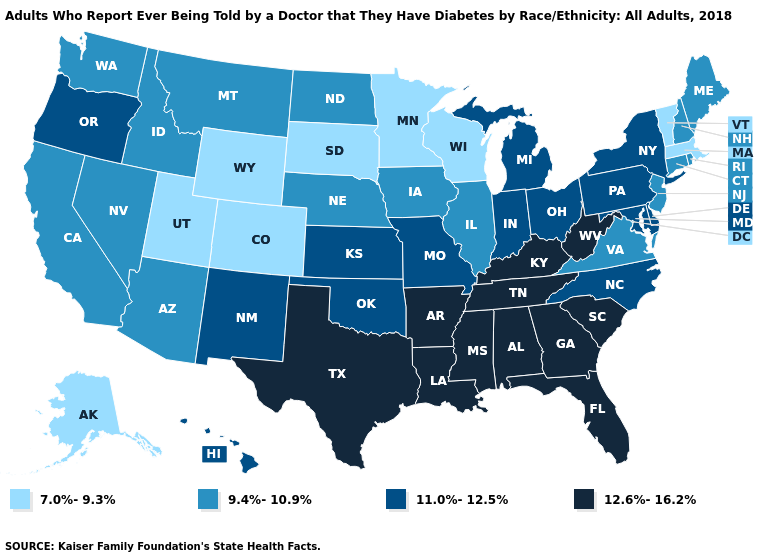Does the map have missing data?
Give a very brief answer. No. What is the value of Minnesota?
Answer briefly. 7.0%-9.3%. Does the first symbol in the legend represent the smallest category?
Keep it brief. Yes. Which states have the lowest value in the USA?
Be succinct. Alaska, Colorado, Massachusetts, Minnesota, South Dakota, Utah, Vermont, Wisconsin, Wyoming. Among the states that border Delaware , which have the lowest value?
Quick response, please. New Jersey. What is the lowest value in the MidWest?
Short answer required. 7.0%-9.3%. Does Pennsylvania have the lowest value in the USA?
Be succinct. No. Does South Dakota have a lower value than Massachusetts?
Short answer required. No. Name the states that have a value in the range 7.0%-9.3%?
Be succinct. Alaska, Colorado, Massachusetts, Minnesota, South Dakota, Utah, Vermont, Wisconsin, Wyoming. What is the value of Rhode Island?
Short answer required. 9.4%-10.9%. What is the value of Hawaii?
Give a very brief answer. 11.0%-12.5%. Does New Mexico have a lower value than Tennessee?
Keep it brief. Yes. Does Pennsylvania have the highest value in the USA?
Short answer required. No. What is the lowest value in the USA?
Write a very short answer. 7.0%-9.3%. 